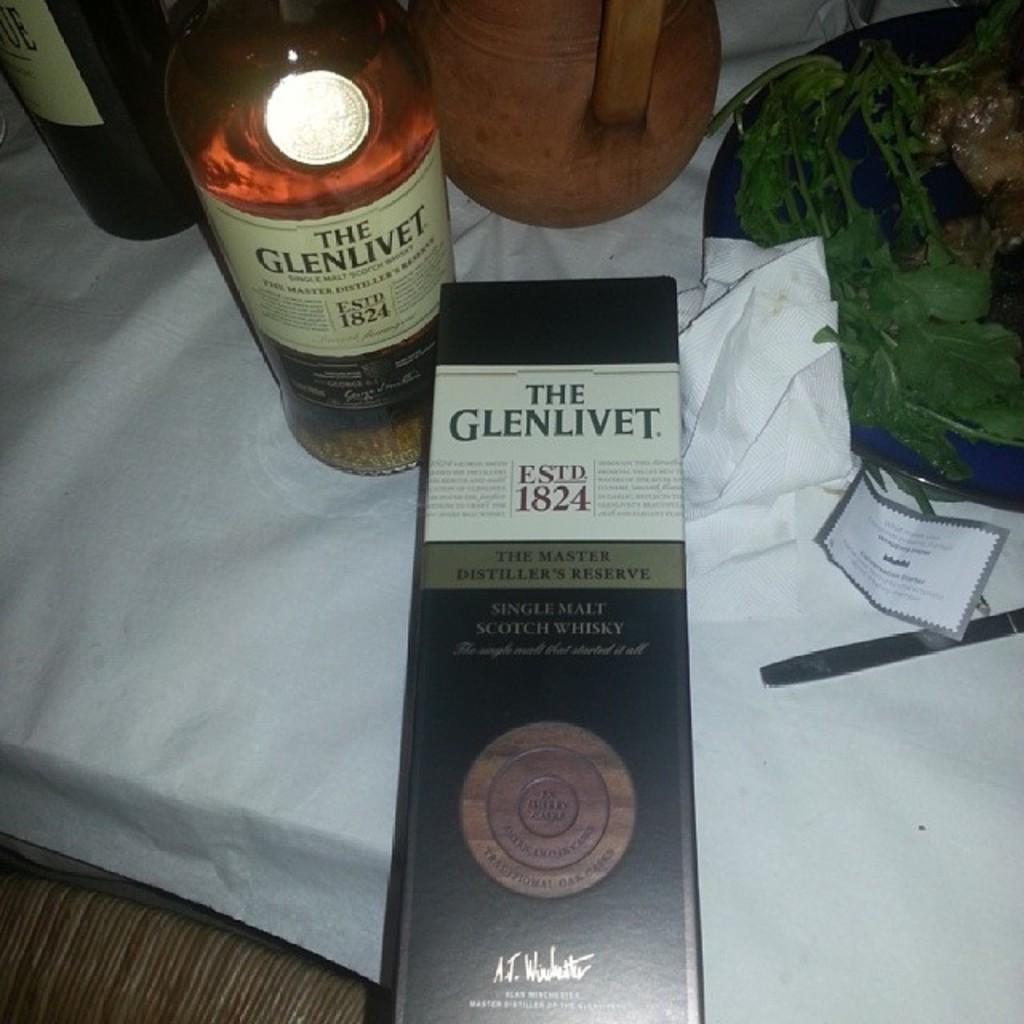<image>
Write a terse but informative summary of the picture. A bottle of Glenlivet Whisky is on a table next to the box it came in. 